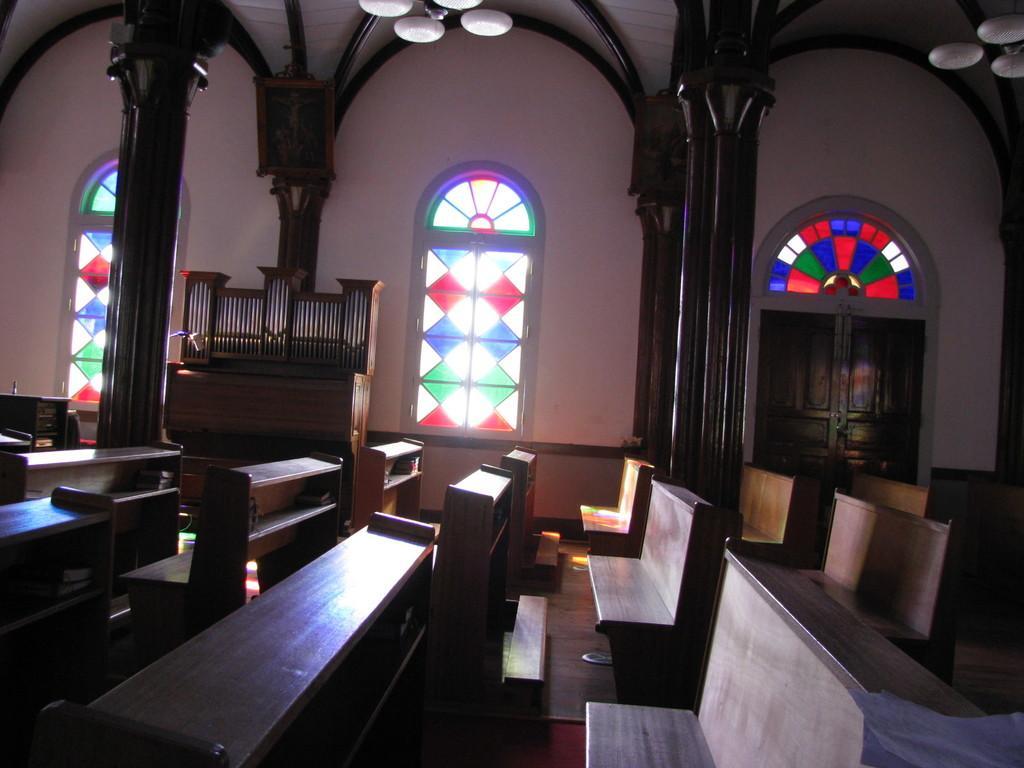Describe this image in one or two sentences. This is a room. In this room there are many benches and desks. In the back there are pillars, cupboards and windows with colorful glasses. Also there is a door. Above that there is a window with colorful glasses. On the ceiling there are chandeliers. 